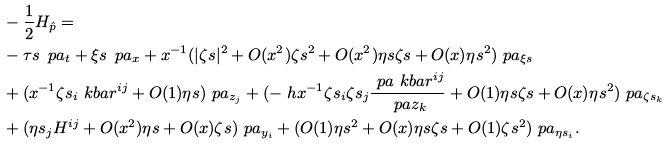<formula> <loc_0><loc_0><loc_500><loc_500>& - \frac { 1 } { 2 } H _ { \hat { p } } = \\ & - \tau s \, \ p a _ { t } + \xi s \, \ p a _ { x } + x ^ { - 1 } ( | \zeta s | ^ { 2 } + O ( x ^ { 2 } ) \zeta s ^ { 2 } + O ( x ^ { 2 } ) \eta s \zeta s + O ( x ) \eta s ^ { 2 } ) \ p a _ { \xi s } \\ & + ( x ^ { - 1 } \zeta s _ { i } \ k b a r ^ { i j } + O ( 1 ) \eta s ) \ p a _ { z _ { j } } + ( - \ h x ^ { - 1 } \zeta s _ { i } \zeta s _ { j } \frac { \ p a \ k b a r ^ { i j } } { \ p a z _ { k } } + O ( 1 ) \eta s \zeta s + O ( x ) \eta s ^ { 2 } ) \ p a _ { \zeta s _ { k } } \\ & + ( \eta s _ { j } H ^ { i j } + O ( x ^ { 2 } ) \eta s + O ( x ) \zeta s ) \ p a _ { y _ { i } } + ( O ( 1 ) \eta s ^ { 2 } + O ( x ) \eta s \zeta s + O ( 1 ) \zeta s ^ { 2 } ) \ p a _ { \eta s _ { i } } .</formula> 